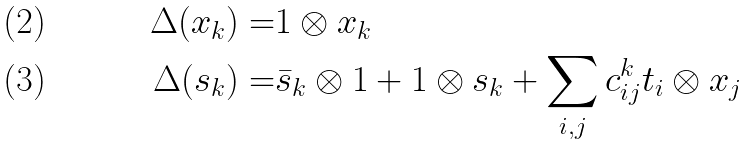<formula> <loc_0><loc_0><loc_500><loc_500>\Delta ( x _ { k } ) = & 1 \otimes x _ { k } \\ \Delta ( s _ { k } ) = & \bar { s } _ { k } \otimes 1 + 1 \otimes s _ { k } + \sum _ { i , j } c _ { i j } ^ { k } t _ { i } \otimes x _ { j }</formula> 